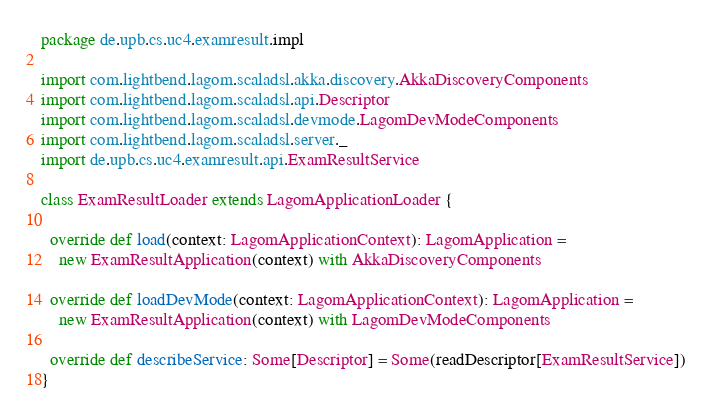<code> <loc_0><loc_0><loc_500><loc_500><_Scala_>package de.upb.cs.uc4.examresult.impl

import com.lightbend.lagom.scaladsl.akka.discovery.AkkaDiscoveryComponents
import com.lightbend.lagom.scaladsl.api.Descriptor
import com.lightbend.lagom.scaladsl.devmode.LagomDevModeComponents
import com.lightbend.lagom.scaladsl.server._
import de.upb.cs.uc4.examresult.api.ExamResultService

class ExamResultLoader extends LagomApplicationLoader {

  override def load(context: LagomApplicationContext): LagomApplication =
    new ExamResultApplication(context) with AkkaDiscoveryComponents

  override def loadDevMode(context: LagomApplicationContext): LagomApplication =
    new ExamResultApplication(context) with LagomDevModeComponents

  override def describeService: Some[Descriptor] = Some(readDescriptor[ExamResultService])
}

</code> 